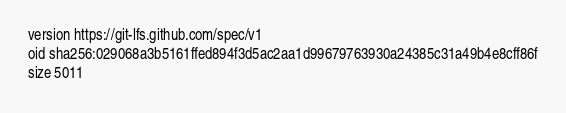Convert code to text. <code><loc_0><loc_0><loc_500><loc_500><_HTML_>version https://git-lfs.github.com/spec/v1
oid sha256:029068a3b5161ffed894f3d5ac2aa1d99679763930a24385c31a49b4e8cff86f
size 5011
</code> 